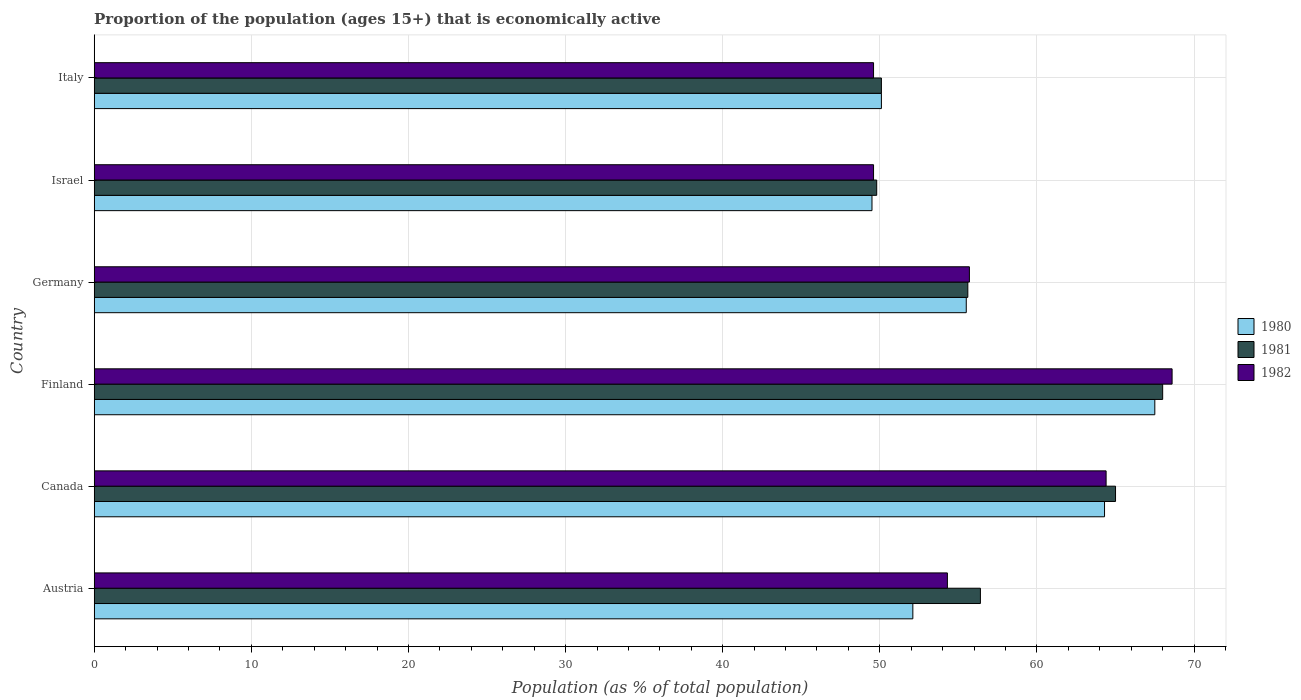How many different coloured bars are there?
Make the answer very short. 3. Are the number of bars per tick equal to the number of legend labels?
Your answer should be very brief. Yes. Are the number of bars on each tick of the Y-axis equal?
Provide a succinct answer. Yes. How many bars are there on the 4th tick from the bottom?
Give a very brief answer. 3. What is the label of the 4th group of bars from the top?
Keep it short and to the point. Finland. What is the proportion of the population that is economically active in 1980 in Canada?
Offer a terse response. 64.3. Across all countries, what is the maximum proportion of the population that is economically active in 1980?
Give a very brief answer. 67.5. Across all countries, what is the minimum proportion of the population that is economically active in 1981?
Provide a succinct answer. 49.8. In which country was the proportion of the population that is economically active in 1982 maximum?
Your answer should be compact. Finland. In which country was the proportion of the population that is economically active in 1980 minimum?
Your answer should be compact. Israel. What is the total proportion of the population that is economically active in 1981 in the graph?
Provide a succinct answer. 344.9. What is the difference between the proportion of the population that is economically active in 1981 in Canada and that in Israel?
Your answer should be very brief. 15.2. What is the difference between the proportion of the population that is economically active in 1982 in Italy and the proportion of the population that is economically active in 1981 in Finland?
Ensure brevity in your answer.  -18.4. What is the average proportion of the population that is economically active in 1981 per country?
Provide a succinct answer. 57.48. What is the difference between the proportion of the population that is economically active in 1980 and proportion of the population that is economically active in 1981 in Austria?
Make the answer very short. -4.3. In how many countries, is the proportion of the population that is economically active in 1980 greater than 70 %?
Your answer should be very brief. 0. What is the ratio of the proportion of the population that is economically active in 1981 in Finland to that in Germany?
Keep it short and to the point. 1.22. Is the proportion of the population that is economically active in 1980 in Canada less than that in Italy?
Offer a terse response. No. In how many countries, is the proportion of the population that is economically active in 1980 greater than the average proportion of the population that is economically active in 1980 taken over all countries?
Provide a short and direct response. 2. Is the sum of the proportion of the population that is economically active in 1982 in Canada and Israel greater than the maximum proportion of the population that is economically active in 1980 across all countries?
Offer a very short reply. Yes. Are all the bars in the graph horizontal?
Give a very brief answer. Yes. How many countries are there in the graph?
Ensure brevity in your answer.  6. What is the difference between two consecutive major ticks on the X-axis?
Offer a terse response. 10. Are the values on the major ticks of X-axis written in scientific E-notation?
Offer a terse response. No. What is the title of the graph?
Provide a succinct answer. Proportion of the population (ages 15+) that is economically active. What is the label or title of the X-axis?
Provide a short and direct response. Population (as % of total population). What is the Population (as % of total population) of 1980 in Austria?
Offer a very short reply. 52.1. What is the Population (as % of total population) of 1981 in Austria?
Your response must be concise. 56.4. What is the Population (as % of total population) in 1982 in Austria?
Give a very brief answer. 54.3. What is the Population (as % of total population) in 1980 in Canada?
Your response must be concise. 64.3. What is the Population (as % of total population) of 1981 in Canada?
Give a very brief answer. 65. What is the Population (as % of total population) in 1982 in Canada?
Give a very brief answer. 64.4. What is the Population (as % of total population) in 1980 in Finland?
Provide a succinct answer. 67.5. What is the Population (as % of total population) of 1982 in Finland?
Offer a terse response. 68.6. What is the Population (as % of total population) of 1980 in Germany?
Ensure brevity in your answer.  55.5. What is the Population (as % of total population) of 1981 in Germany?
Offer a very short reply. 55.6. What is the Population (as % of total population) in 1982 in Germany?
Offer a terse response. 55.7. What is the Population (as % of total population) of 1980 in Israel?
Keep it short and to the point. 49.5. What is the Population (as % of total population) of 1981 in Israel?
Offer a very short reply. 49.8. What is the Population (as % of total population) of 1982 in Israel?
Keep it short and to the point. 49.6. What is the Population (as % of total population) of 1980 in Italy?
Your answer should be compact. 50.1. What is the Population (as % of total population) of 1981 in Italy?
Your answer should be compact. 50.1. What is the Population (as % of total population) in 1982 in Italy?
Keep it short and to the point. 49.6. Across all countries, what is the maximum Population (as % of total population) in 1980?
Make the answer very short. 67.5. Across all countries, what is the maximum Population (as % of total population) of 1981?
Offer a very short reply. 68. Across all countries, what is the maximum Population (as % of total population) of 1982?
Offer a very short reply. 68.6. Across all countries, what is the minimum Population (as % of total population) of 1980?
Offer a very short reply. 49.5. Across all countries, what is the minimum Population (as % of total population) in 1981?
Keep it short and to the point. 49.8. Across all countries, what is the minimum Population (as % of total population) of 1982?
Give a very brief answer. 49.6. What is the total Population (as % of total population) in 1980 in the graph?
Give a very brief answer. 339. What is the total Population (as % of total population) in 1981 in the graph?
Keep it short and to the point. 344.9. What is the total Population (as % of total population) of 1982 in the graph?
Your response must be concise. 342.2. What is the difference between the Population (as % of total population) in 1980 in Austria and that in Finland?
Make the answer very short. -15.4. What is the difference between the Population (as % of total population) of 1982 in Austria and that in Finland?
Ensure brevity in your answer.  -14.3. What is the difference between the Population (as % of total population) in 1980 in Austria and that in Germany?
Offer a terse response. -3.4. What is the difference between the Population (as % of total population) in 1982 in Austria and that in Germany?
Make the answer very short. -1.4. What is the difference between the Population (as % of total population) in 1981 in Austria and that in Italy?
Offer a very short reply. 6.3. What is the difference between the Population (as % of total population) in 1981 in Canada and that in Finland?
Your response must be concise. -3. What is the difference between the Population (as % of total population) of 1982 in Canada and that in Finland?
Offer a very short reply. -4.2. What is the difference between the Population (as % of total population) of 1980 in Canada and that in Germany?
Offer a terse response. 8.8. What is the difference between the Population (as % of total population) of 1981 in Canada and that in Italy?
Make the answer very short. 14.9. What is the difference between the Population (as % of total population) of 1982 in Canada and that in Italy?
Your response must be concise. 14.8. What is the difference between the Population (as % of total population) in 1980 in Finland and that in Germany?
Your response must be concise. 12. What is the difference between the Population (as % of total population) in 1981 in Finland and that in Germany?
Provide a short and direct response. 12.4. What is the difference between the Population (as % of total population) of 1981 in Finland and that in Israel?
Keep it short and to the point. 18.2. What is the difference between the Population (as % of total population) in 1980 in Finland and that in Italy?
Make the answer very short. 17.4. What is the difference between the Population (as % of total population) in 1981 in Finland and that in Italy?
Provide a short and direct response. 17.9. What is the difference between the Population (as % of total population) in 1980 in Germany and that in Israel?
Keep it short and to the point. 6. What is the difference between the Population (as % of total population) in 1980 in Germany and that in Italy?
Make the answer very short. 5.4. What is the difference between the Population (as % of total population) in 1981 in Germany and that in Italy?
Offer a very short reply. 5.5. What is the difference between the Population (as % of total population) of 1981 in Israel and that in Italy?
Make the answer very short. -0.3. What is the difference between the Population (as % of total population) of 1982 in Israel and that in Italy?
Provide a short and direct response. 0. What is the difference between the Population (as % of total population) of 1980 in Austria and the Population (as % of total population) of 1981 in Canada?
Provide a short and direct response. -12.9. What is the difference between the Population (as % of total population) of 1981 in Austria and the Population (as % of total population) of 1982 in Canada?
Your response must be concise. -8. What is the difference between the Population (as % of total population) in 1980 in Austria and the Population (as % of total population) in 1981 in Finland?
Your answer should be compact. -15.9. What is the difference between the Population (as % of total population) in 1980 in Austria and the Population (as % of total population) in 1982 in Finland?
Your response must be concise. -16.5. What is the difference between the Population (as % of total population) in 1980 in Austria and the Population (as % of total population) in 1981 in Germany?
Keep it short and to the point. -3.5. What is the difference between the Population (as % of total population) of 1981 in Austria and the Population (as % of total population) of 1982 in Germany?
Give a very brief answer. 0.7. What is the difference between the Population (as % of total population) of 1980 in Austria and the Population (as % of total population) of 1982 in Israel?
Make the answer very short. 2.5. What is the difference between the Population (as % of total population) of 1981 in Austria and the Population (as % of total population) of 1982 in Israel?
Your response must be concise. 6.8. What is the difference between the Population (as % of total population) in 1980 in Austria and the Population (as % of total population) in 1982 in Italy?
Your answer should be very brief. 2.5. What is the difference between the Population (as % of total population) of 1980 in Canada and the Population (as % of total population) of 1981 in Finland?
Ensure brevity in your answer.  -3.7. What is the difference between the Population (as % of total population) in 1980 in Canada and the Population (as % of total population) in 1982 in Finland?
Offer a very short reply. -4.3. What is the difference between the Population (as % of total population) of 1980 in Canada and the Population (as % of total population) of 1981 in Germany?
Provide a succinct answer. 8.7. What is the difference between the Population (as % of total population) of 1980 in Canada and the Population (as % of total population) of 1982 in Germany?
Your answer should be compact. 8.6. What is the difference between the Population (as % of total population) in 1980 in Canada and the Population (as % of total population) in 1982 in Israel?
Provide a succinct answer. 14.7. What is the difference between the Population (as % of total population) in 1980 in Canada and the Population (as % of total population) in 1981 in Italy?
Keep it short and to the point. 14.2. What is the difference between the Population (as % of total population) in 1981 in Canada and the Population (as % of total population) in 1982 in Italy?
Provide a short and direct response. 15.4. What is the difference between the Population (as % of total population) in 1980 in Finland and the Population (as % of total population) in 1981 in Germany?
Offer a very short reply. 11.9. What is the difference between the Population (as % of total population) of 1980 in Finland and the Population (as % of total population) of 1982 in Germany?
Provide a succinct answer. 11.8. What is the difference between the Population (as % of total population) of 1980 in Finland and the Population (as % of total population) of 1982 in Israel?
Offer a terse response. 17.9. What is the difference between the Population (as % of total population) of 1980 in Finland and the Population (as % of total population) of 1981 in Italy?
Provide a succinct answer. 17.4. What is the difference between the Population (as % of total population) of 1980 in Finland and the Population (as % of total population) of 1982 in Italy?
Give a very brief answer. 17.9. What is the difference between the Population (as % of total population) of 1980 in Germany and the Population (as % of total population) of 1982 in Israel?
Your answer should be very brief. 5.9. What is the difference between the Population (as % of total population) of 1980 in Germany and the Population (as % of total population) of 1981 in Italy?
Provide a succinct answer. 5.4. What is the difference between the Population (as % of total population) in 1980 in Germany and the Population (as % of total population) in 1982 in Italy?
Give a very brief answer. 5.9. What is the difference between the Population (as % of total population) of 1981 in Germany and the Population (as % of total population) of 1982 in Italy?
Your answer should be very brief. 6. What is the difference between the Population (as % of total population) in 1980 in Israel and the Population (as % of total population) in 1981 in Italy?
Your answer should be compact. -0.6. What is the difference between the Population (as % of total population) in 1980 in Israel and the Population (as % of total population) in 1982 in Italy?
Your answer should be compact. -0.1. What is the average Population (as % of total population) in 1980 per country?
Offer a terse response. 56.5. What is the average Population (as % of total population) in 1981 per country?
Your response must be concise. 57.48. What is the average Population (as % of total population) of 1982 per country?
Offer a terse response. 57.03. What is the difference between the Population (as % of total population) in 1980 and Population (as % of total population) in 1982 in Austria?
Provide a succinct answer. -2.2. What is the difference between the Population (as % of total population) of 1981 and Population (as % of total population) of 1982 in Canada?
Your answer should be compact. 0.6. What is the difference between the Population (as % of total population) in 1980 and Population (as % of total population) in 1981 in Finland?
Offer a terse response. -0.5. What is the difference between the Population (as % of total population) of 1980 and Population (as % of total population) of 1982 in Finland?
Offer a terse response. -1.1. What is the difference between the Population (as % of total population) in 1981 and Population (as % of total population) in 1982 in Finland?
Your answer should be compact. -0.6. What is the difference between the Population (as % of total population) in 1981 and Population (as % of total population) in 1982 in Germany?
Provide a succinct answer. -0.1. What is the difference between the Population (as % of total population) in 1980 and Population (as % of total population) in 1981 in Israel?
Ensure brevity in your answer.  -0.3. What is the difference between the Population (as % of total population) of 1980 and Population (as % of total population) of 1982 in Israel?
Offer a very short reply. -0.1. What is the difference between the Population (as % of total population) in 1980 and Population (as % of total population) in 1981 in Italy?
Give a very brief answer. 0. What is the ratio of the Population (as % of total population) in 1980 in Austria to that in Canada?
Your response must be concise. 0.81. What is the ratio of the Population (as % of total population) of 1981 in Austria to that in Canada?
Offer a very short reply. 0.87. What is the ratio of the Population (as % of total population) of 1982 in Austria to that in Canada?
Offer a terse response. 0.84. What is the ratio of the Population (as % of total population) in 1980 in Austria to that in Finland?
Provide a short and direct response. 0.77. What is the ratio of the Population (as % of total population) in 1981 in Austria to that in Finland?
Your answer should be very brief. 0.83. What is the ratio of the Population (as % of total population) in 1982 in Austria to that in Finland?
Provide a succinct answer. 0.79. What is the ratio of the Population (as % of total population) of 1980 in Austria to that in Germany?
Give a very brief answer. 0.94. What is the ratio of the Population (as % of total population) in 1981 in Austria to that in Germany?
Provide a short and direct response. 1.01. What is the ratio of the Population (as % of total population) in 1982 in Austria to that in Germany?
Your response must be concise. 0.97. What is the ratio of the Population (as % of total population) in 1980 in Austria to that in Israel?
Provide a succinct answer. 1.05. What is the ratio of the Population (as % of total population) in 1981 in Austria to that in Israel?
Give a very brief answer. 1.13. What is the ratio of the Population (as % of total population) of 1982 in Austria to that in Israel?
Give a very brief answer. 1.09. What is the ratio of the Population (as % of total population) of 1980 in Austria to that in Italy?
Keep it short and to the point. 1.04. What is the ratio of the Population (as % of total population) in 1981 in Austria to that in Italy?
Your response must be concise. 1.13. What is the ratio of the Population (as % of total population) of 1982 in Austria to that in Italy?
Offer a terse response. 1.09. What is the ratio of the Population (as % of total population) of 1980 in Canada to that in Finland?
Your answer should be very brief. 0.95. What is the ratio of the Population (as % of total population) of 1981 in Canada to that in Finland?
Provide a succinct answer. 0.96. What is the ratio of the Population (as % of total population) of 1982 in Canada to that in Finland?
Offer a very short reply. 0.94. What is the ratio of the Population (as % of total population) in 1980 in Canada to that in Germany?
Give a very brief answer. 1.16. What is the ratio of the Population (as % of total population) in 1981 in Canada to that in Germany?
Your answer should be compact. 1.17. What is the ratio of the Population (as % of total population) in 1982 in Canada to that in Germany?
Make the answer very short. 1.16. What is the ratio of the Population (as % of total population) in 1980 in Canada to that in Israel?
Your response must be concise. 1.3. What is the ratio of the Population (as % of total population) of 1981 in Canada to that in Israel?
Offer a terse response. 1.31. What is the ratio of the Population (as % of total population) in 1982 in Canada to that in Israel?
Your answer should be compact. 1.3. What is the ratio of the Population (as % of total population) in 1980 in Canada to that in Italy?
Make the answer very short. 1.28. What is the ratio of the Population (as % of total population) of 1981 in Canada to that in Italy?
Offer a very short reply. 1.3. What is the ratio of the Population (as % of total population) of 1982 in Canada to that in Italy?
Your answer should be very brief. 1.3. What is the ratio of the Population (as % of total population) in 1980 in Finland to that in Germany?
Your answer should be compact. 1.22. What is the ratio of the Population (as % of total population) of 1981 in Finland to that in Germany?
Provide a short and direct response. 1.22. What is the ratio of the Population (as % of total population) in 1982 in Finland to that in Germany?
Your answer should be compact. 1.23. What is the ratio of the Population (as % of total population) of 1980 in Finland to that in Israel?
Offer a very short reply. 1.36. What is the ratio of the Population (as % of total population) in 1981 in Finland to that in Israel?
Your answer should be compact. 1.37. What is the ratio of the Population (as % of total population) in 1982 in Finland to that in Israel?
Give a very brief answer. 1.38. What is the ratio of the Population (as % of total population) of 1980 in Finland to that in Italy?
Offer a terse response. 1.35. What is the ratio of the Population (as % of total population) of 1981 in Finland to that in Italy?
Offer a very short reply. 1.36. What is the ratio of the Population (as % of total population) of 1982 in Finland to that in Italy?
Give a very brief answer. 1.38. What is the ratio of the Population (as % of total population) in 1980 in Germany to that in Israel?
Your answer should be compact. 1.12. What is the ratio of the Population (as % of total population) in 1981 in Germany to that in Israel?
Make the answer very short. 1.12. What is the ratio of the Population (as % of total population) of 1982 in Germany to that in Israel?
Offer a terse response. 1.12. What is the ratio of the Population (as % of total population) of 1980 in Germany to that in Italy?
Your answer should be very brief. 1.11. What is the ratio of the Population (as % of total population) of 1981 in Germany to that in Italy?
Give a very brief answer. 1.11. What is the ratio of the Population (as % of total population) in 1982 in Germany to that in Italy?
Your answer should be very brief. 1.12. What is the ratio of the Population (as % of total population) of 1980 in Israel to that in Italy?
Your response must be concise. 0.99. What is the difference between the highest and the second highest Population (as % of total population) of 1980?
Provide a short and direct response. 3.2. What is the difference between the highest and the second highest Population (as % of total population) of 1982?
Give a very brief answer. 4.2. 